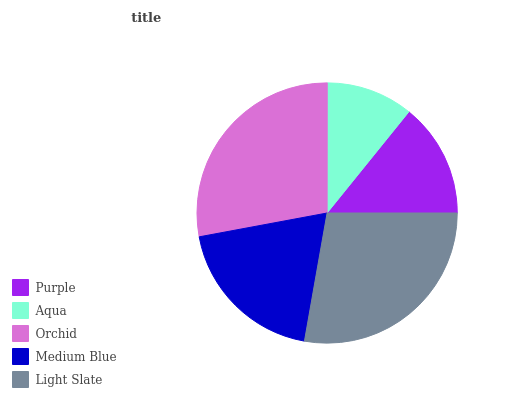Is Aqua the minimum?
Answer yes or no. Yes. Is Orchid the maximum?
Answer yes or no. Yes. Is Orchid the minimum?
Answer yes or no. No. Is Aqua the maximum?
Answer yes or no. No. Is Orchid greater than Aqua?
Answer yes or no. Yes. Is Aqua less than Orchid?
Answer yes or no. Yes. Is Aqua greater than Orchid?
Answer yes or no. No. Is Orchid less than Aqua?
Answer yes or no. No. Is Medium Blue the high median?
Answer yes or no. Yes. Is Medium Blue the low median?
Answer yes or no. Yes. Is Purple the high median?
Answer yes or no. No. Is Purple the low median?
Answer yes or no. No. 